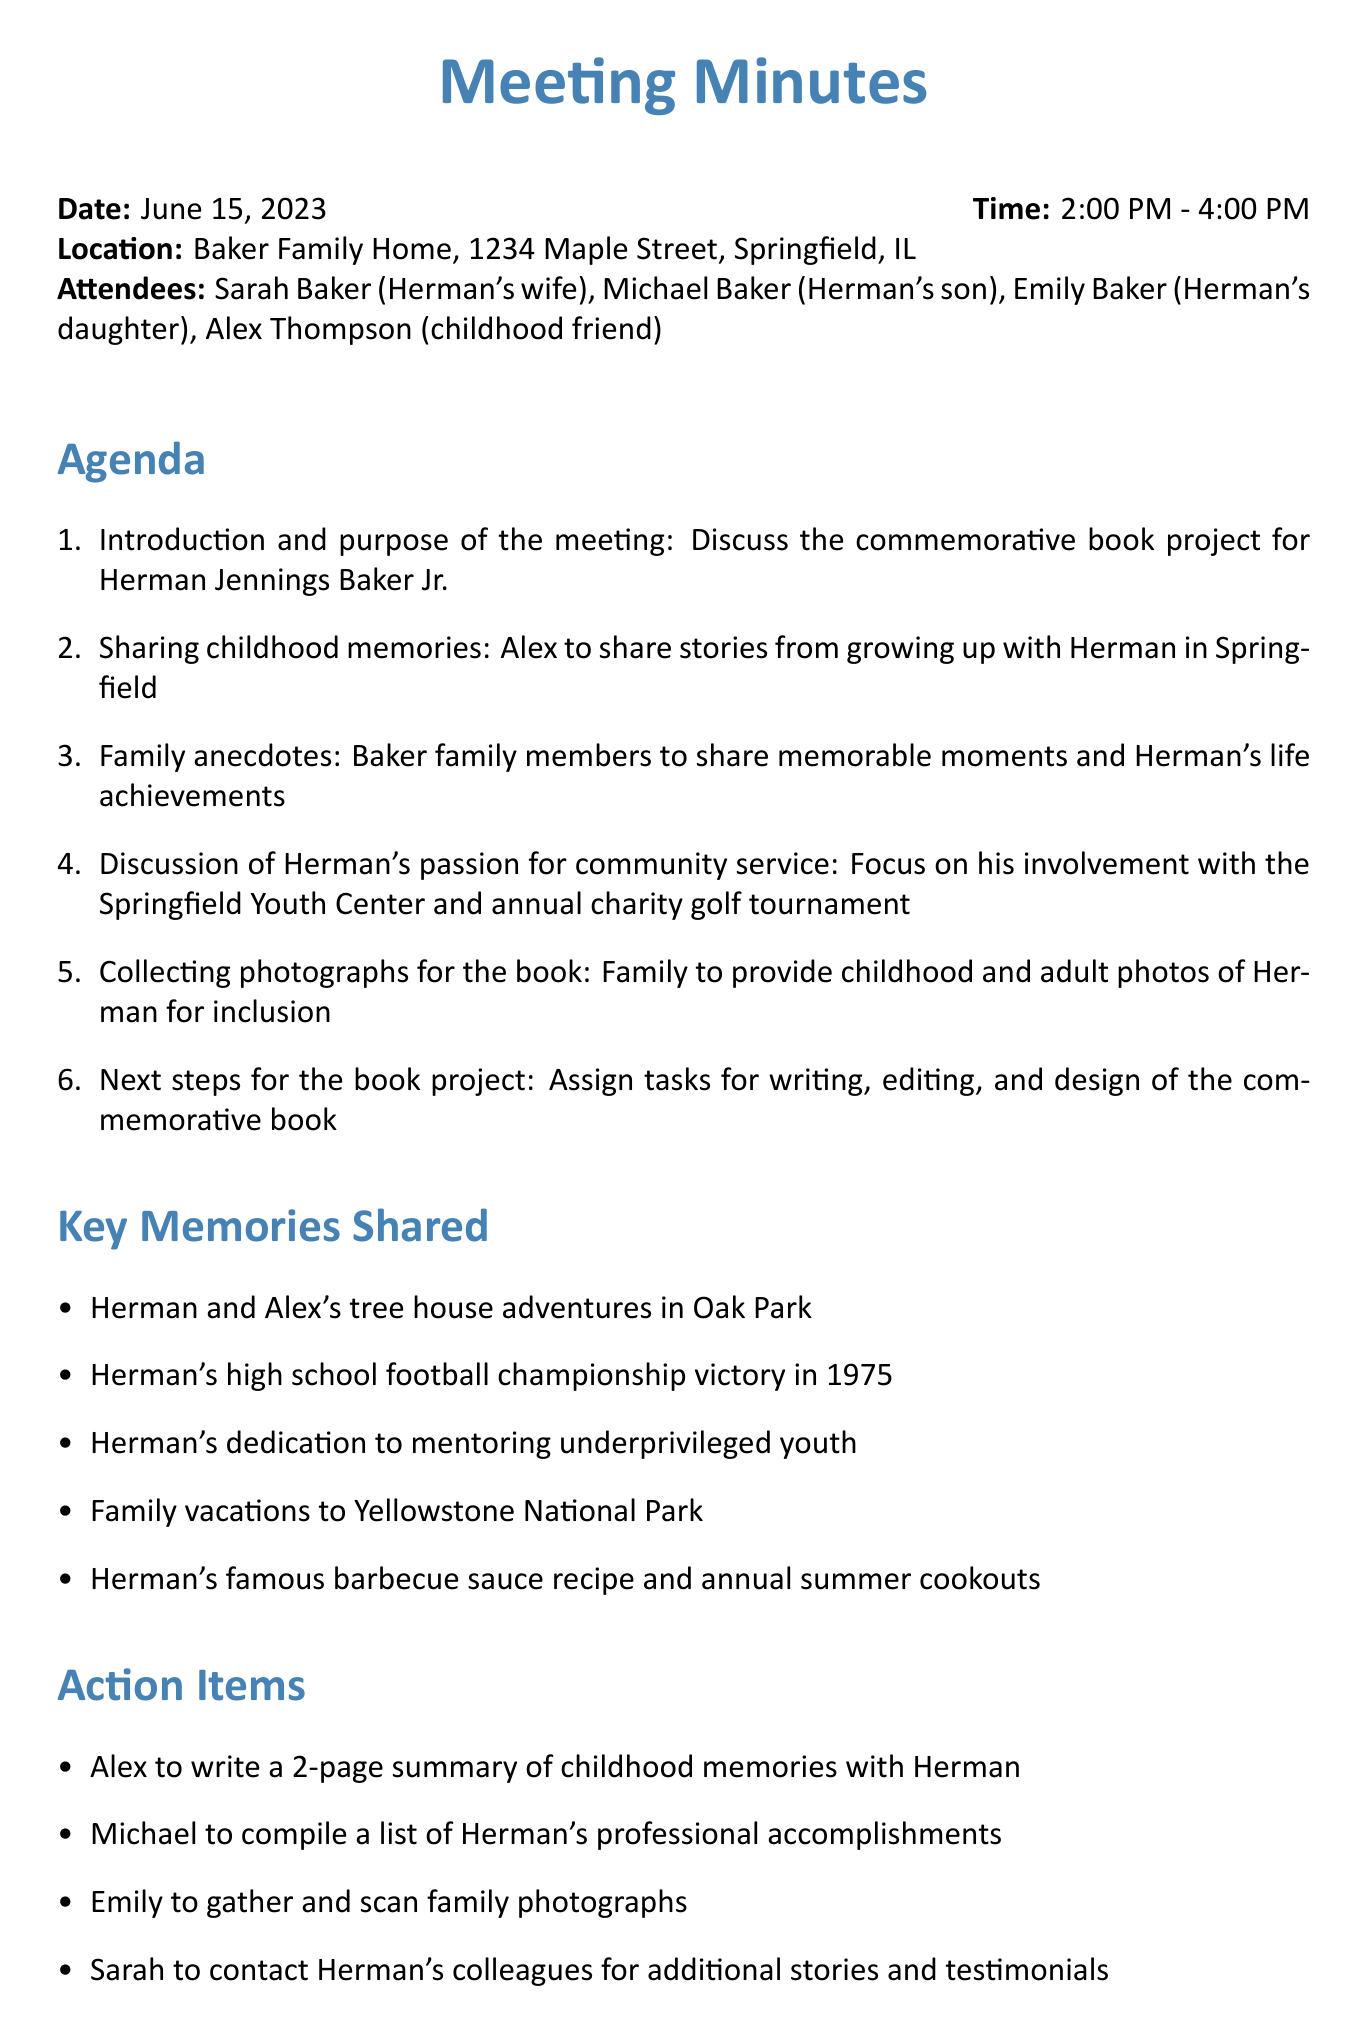What is the date of the meeting? The date of the meeting is clearly stated in the document, which is June 15, 2023.
Answer: June 15, 2023 Who is Herman's wife? The document lists Sarah Baker as Herman's wife during the meeting.
Answer: Sarah Baker What was discussed in the agenda item about childhood memories? The agenda item focuses on sharing stories from Alex's experiences growing up with Herman in Springfield.
Answer: Alex to share stories How long did the meeting last? The document provides the start and end times of the meeting, indicating it lasted for two hours.
Answer: 2 hours What is one key memory shared during the meeting? The document lists specific memories, including Herman and Alex's tree house adventures.
Answer: Tree house adventures Who is responsible for gathering family photographs? The action item indicates that Emily will gather and scan family photographs for the book.
Answer: Emily What is the purpose of the commemorative book project? The introduction outlines that the purpose is to commemorate Herman Jennings Baker Jr.
Answer: To commemorate Herman When is the deadline for reviewing the final book layout? The document specifies that all attendees need to review the final book layout by August 1, 2023.
Answer: August 1, 2023 